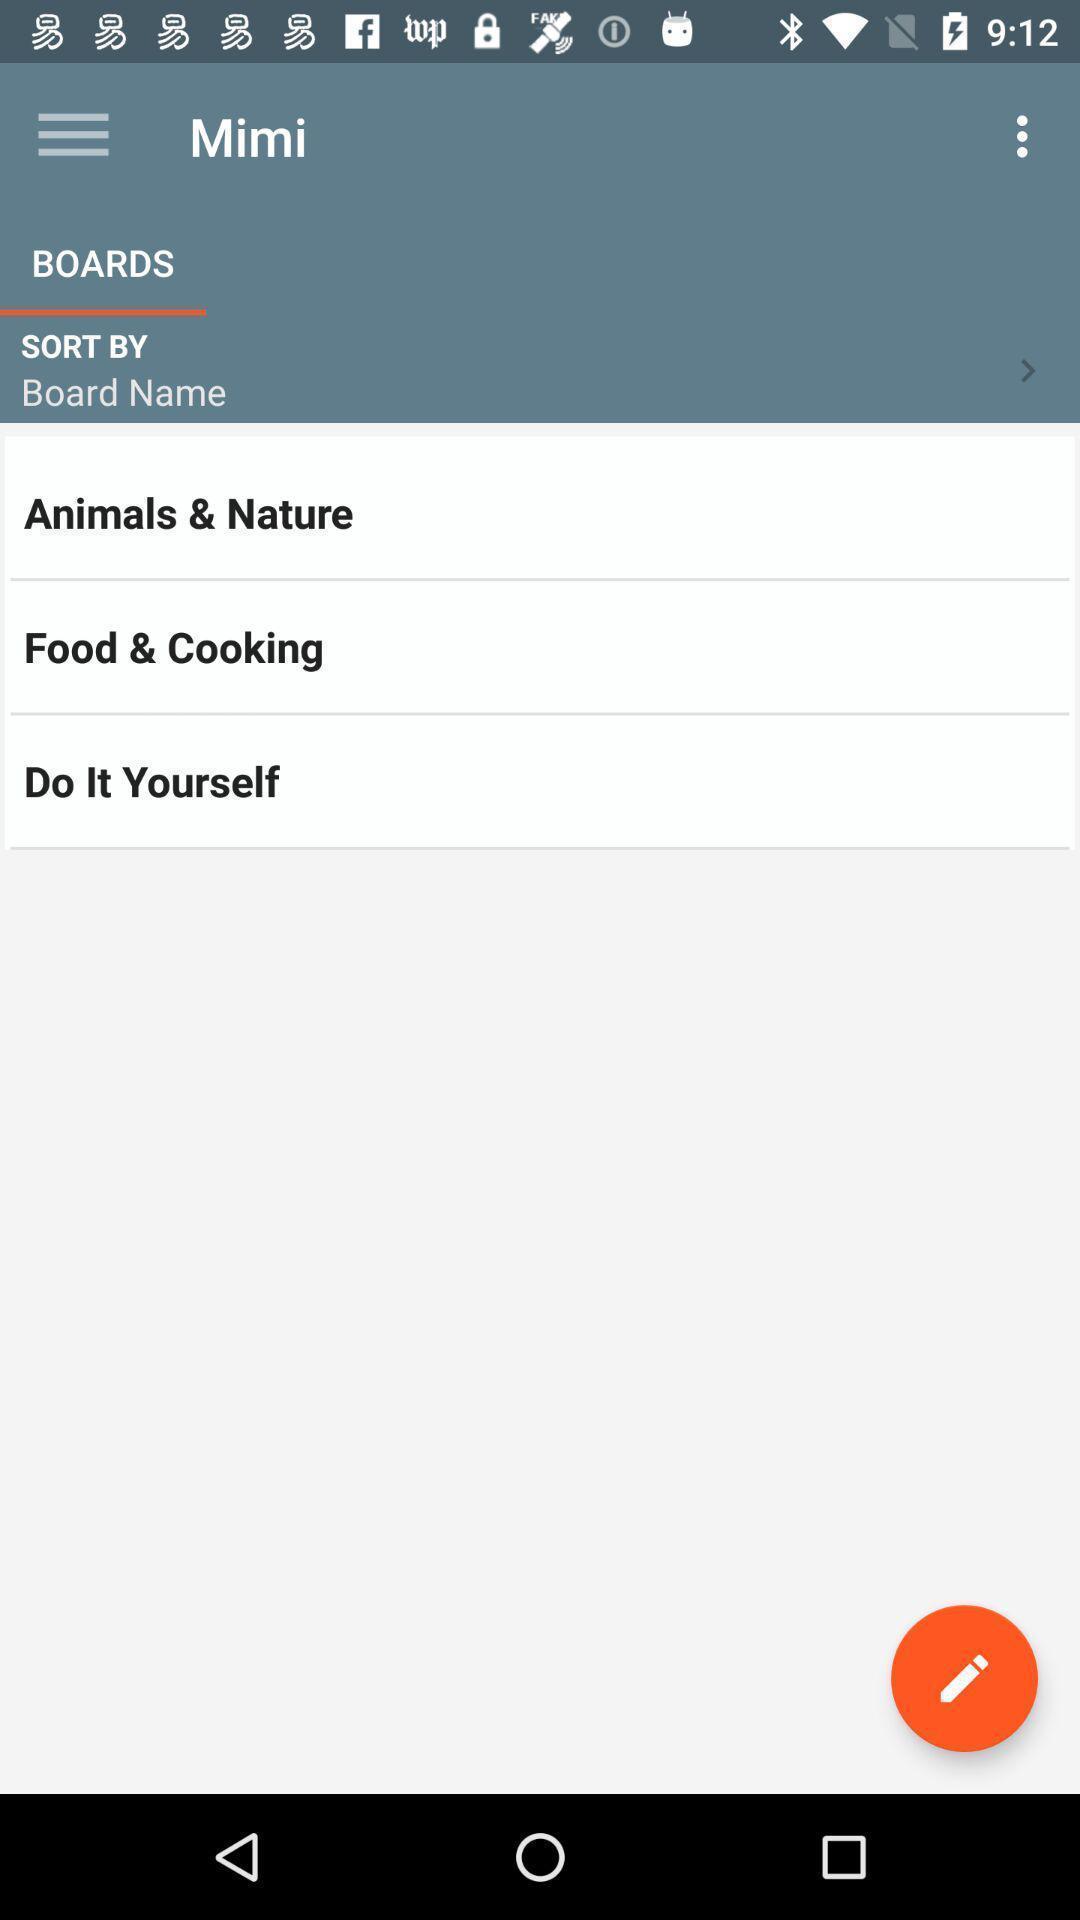What can you discern from this picture? Page displaying list of options. 